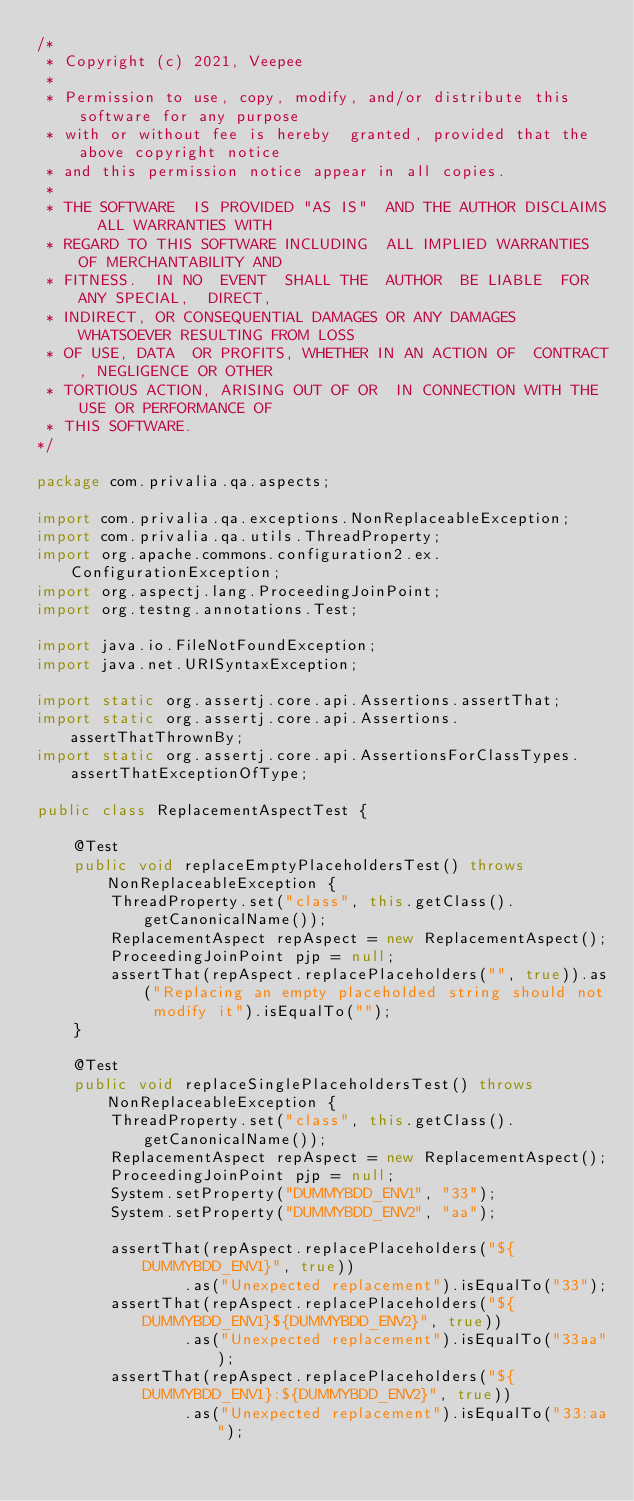<code> <loc_0><loc_0><loc_500><loc_500><_Java_>/*
 * Copyright (c) 2021, Veepee
 *
 * Permission to use, copy, modify, and/or distribute this software for any purpose
 * with or without fee is hereby  granted, provided that the above copyright notice
 * and this permission notice appear in all copies.
 *
 * THE SOFTWARE  IS PROVIDED "AS IS"  AND THE AUTHOR DISCLAIMS  ALL WARRANTIES WITH
 * REGARD TO THIS SOFTWARE INCLUDING  ALL IMPLIED WARRANTIES OF MERCHANTABILITY AND
 * FITNESS.  IN NO  EVENT  SHALL THE  AUTHOR  BE LIABLE  FOR  ANY SPECIAL,  DIRECT,
 * INDIRECT, OR CONSEQUENTIAL DAMAGES OR ANY DAMAGES WHATSOEVER RESULTING FROM LOSS
 * OF USE, DATA  OR PROFITS, WHETHER IN AN ACTION OF  CONTRACT, NEGLIGENCE OR OTHER
 * TORTIOUS ACTION, ARISING OUT OF OR  IN CONNECTION WITH THE USE OR PERFORMANCE OF
 * THIS SOFTWARE.
*/

package com.privalia.qa.aspects;

import com.privalia.qa.exceptions.NonReplaceableException;
import com.privalia.qa.utils.ThreadProperty;
import org.apache.commons.configuration2.ex.ConfigurationException;
import org.aspectj.lang.ProceedingJoinPoint;
import org.testng.annotations.Test;

import java.io.FileNotFoundException;
import java.net.URISyntaxException;

import static org.assertj.core.api.Assertions.assertThat;
import static org.assertj.core.api.Assertions.assertThatThrownBy;
import static org.assertj.core.api.AssertionsForClassTypes.assertThatExceptionOfType;

public class ReplacementAspectTest {

    @Test
    public void replaceEmptyPlaceholdersTest() throws NonReplaceableException {
        ThreadProperty.set("class", this.getClass().getCanonicalName());
        ReplacementAspect repAspect = new ReplacementAspect();
        ProceedingJoinPoint pjp = null;
        assertThat(repAspect.replacePlaceholders("", true)).as("Replacing an empty placeholded string should not modify it").isEqualTo("");
    }

    @Test
    public void replaceSinglePlaceholdersTest() throws NonReplaceableException {
        ThreadProperty.set("class", this.getClass().getCanonicalName());
        ReplacementAspect repAspect = new ReplacementAspect();
        ProceedingJoinPoint pjp = null;
        System.setProperty("DUMMYBDD_ENV1", "33");
        System.setProperty("DUMMYBDD_ENV2", "aa");

        assertThat(repAspect.replacePlaceholders("${DUMMYBDD_ENV1}", true))
                .as("Unexpected replacement").isEqualTo("33");
        assertThat(repAspect.replacePlaceholders("${DUMMYBDD_ENV1}${DUMMYBDD_ENV2}", true))
                .as("Unexpected replacement").isEqualTo("33aa");
        assertThat(repAspect.replacePlaceholders("${DUMMYBDD_ENV1}:${DUMMYBDD_ENV2}", true))
                .as("Unexpected replacement").isEqualTo("33:aa");</code> 